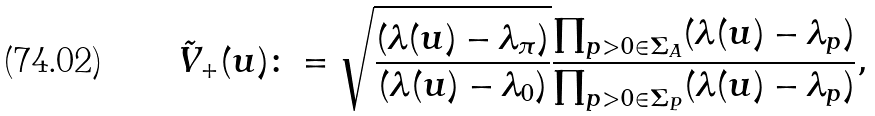Convert formula to latex. <formula><loc_0><loc_0><loc_500><loc_500>\tilde { V } _ { + } ( u ) \colon = \sqrt { \frac { ( \lambda ( u ) - \lambda _ { \pi } ) } { ( \lambda ( u ) - \lambda _ { 0 } ) } } \frac { \prod _ { p > 0 \in \Sigma _ { A } } ( \lambda ( u ) - \lambda _ { p } ) } { \prod _ { p > 0 \in \Sigma _ { P } } ( \lambda ( u ) - \lambda _ { p } ) } ,</formula> 